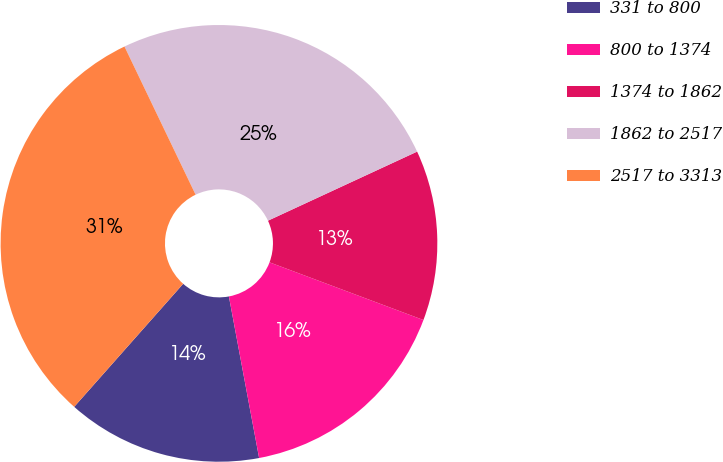Convert chart to OTSL. <chart><loc_0><loc_0><loc_500><loc_500><pie_chart><fcel>331 to 800<fcel>800 to 1374<fcel>1374 to 1862<fcel>1862 to 2517<fcel>2517 to 3313<nl><fcel>14.48%<fcel>16.35%<fcel>12.61%<fcel>25.22%<fcel>31.34%<nl></chart> 